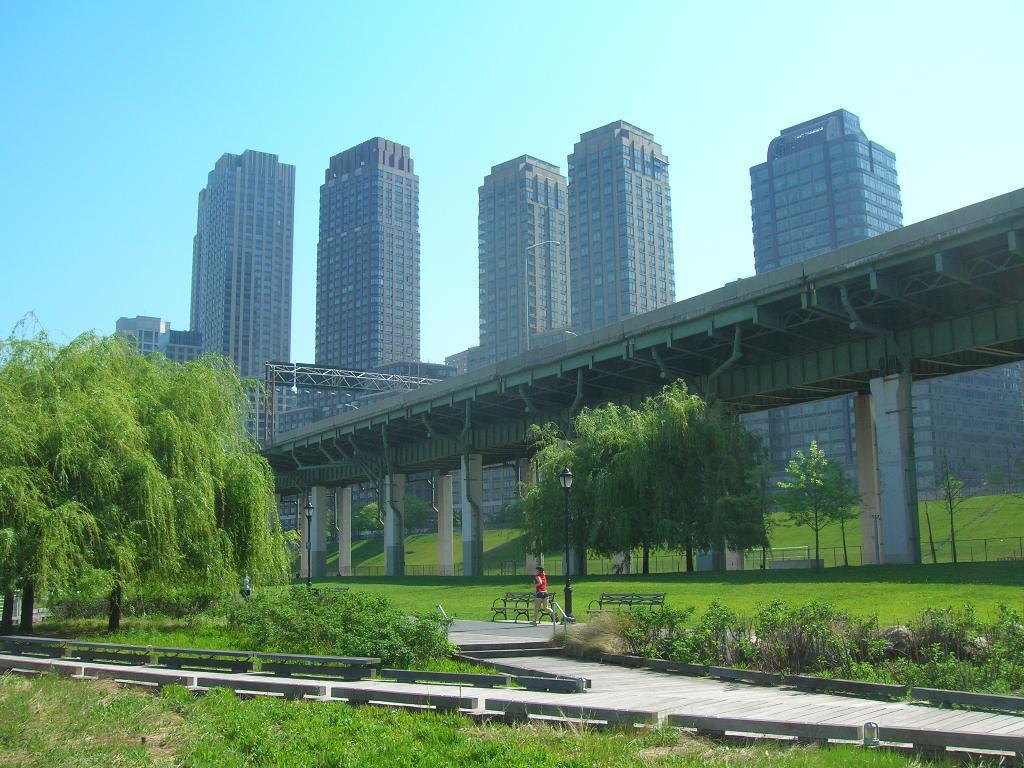Could you give a brief overview of what you see in this image? At the bottom of the picture, we see the grass. Beside that, we see the rods and the pavement. In the middle, we see a woman in the red T-shirt is walking and beside her, we see the benches and a light pole. On the left side, we see the trees. In the middle, we see the trees and a bridge. There are buildings in the background. At the top, we see the sky. 